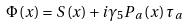Convert formula to latex. <formula><loc_0><loc_0><loc_500><loc_500>\Phi \left ( x \right ) = S \left ( x \right ) + i \gamma _ { 5 } P _ { a } \left ( x \right ) \tau _ { a }</formula> 